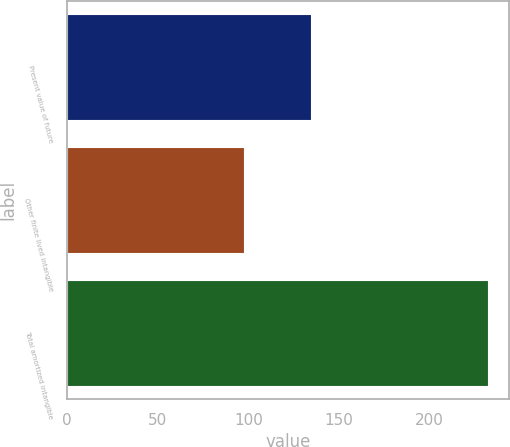<chart> <loc_0><loc_0><loc_500><loc_500><bar_chart><fcel>Present value of future<fcel>Other finite lived intangible<fcel>Total amortized intangible<nl><fcel>134.4<fcel>97.5<fcel>231.9<nl></chart> 